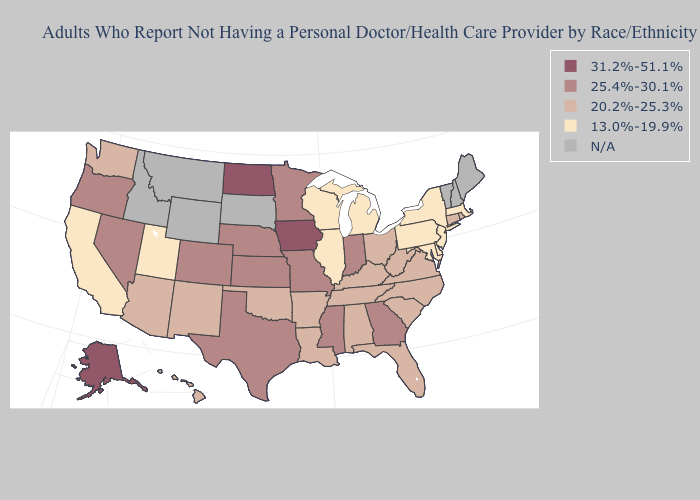Is the legend a continuous bar?
Quick response, please. No. Name the states that have a value in the range N/A?
Keep it brief. Idaho, Maine, Montana, New Hampshire, South Dakota, Vermont, Wyoming. Name the states that have a value in the range 31.2%-51.1%?
Concise answer only. Alaska, Iowa, North Dakota. What is the highest value in the USA?
Quick response, please. 31.2%-51.1%. Name the states that have a value in the range 20.2%-25.3%?
Give a very brief answer. Alabama, Arizona, Arkansas, Connecticut, Florida, Hawaii, Kentucky, Louisiana, New Mexico, North Carolina, Ohio, Oklahoma, Rhode Island, South Carolina, Tennessee, Virginia, Washington, West Virginia. Which states have the lowest value in the MidWest?
Short answer required. Illinois, Michigan, Wisconsin. Does Wisconsin have the highest value in the MidWest?
Give a very brief answer. No. Does Rhode Island have the highest value in the Northeast?
Give a very brief answer. Yes. Name the states that have a value in the range 25.4%-30.1%?
Concise answer only. Colorado, Georgia, Indiana, Kansas, Minnesota, Mississippi, Missouri, Nebraska, Nevada, Oregon, Texas. What is the value of South Dakota?
Answer briefly. N/A. What is the value of South Dakota?
Answer briefly. N/A. What is the lowest value in states that border Kansas?
Give a very brief answer. 20.2%-25.3%. What is the value of Illinois?
Write a very short answer. 13.0%-19.9%. Does the first symbol in the legend represent the smallest category?
Answer briefly. No. 